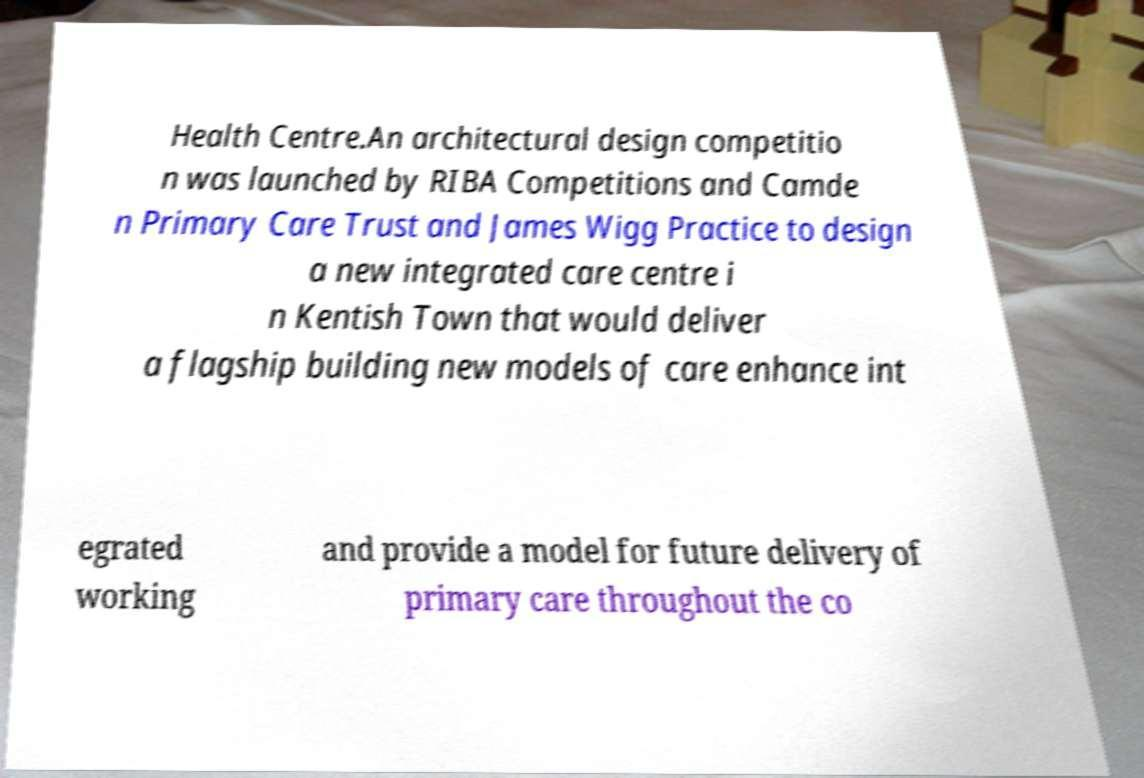Please identify and transcribe the text found in this image. Health Centre.An architectural design competitio n was launched by RIBA Competitions and Camde n Primary Care Trust and James Wigg Practice to design a new integrated care centre i n Kentish Town that would deliver a flagship building new models of care enhance int egrated working and provide a model for future delivery of primary care throughout the co 